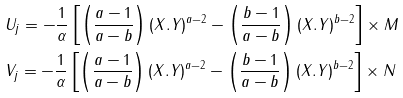<formula> <loc_0><loc_0><loc_500><loc_500>& U _ { j } = - \frac { 1 } { \alpha } \left [ \left ( \frac { a - 1 } { a - b } \right ) ( X . Y ) ^ { a - 2 } - \left ( \frac { b - 1 } { a - b } \right ) ( X . Y ) ^ { b - 2 } \right ] \times M \\ & V _ { j } = - \frac { 1 } { \alpha } \left [ \left ( \frac { a - 1 } { a - b } \right ) ( X . Y ) ^ { a - 2 } - \left ( \frac { b - 1 } { a - b } \right ) ( X . Y ) ^ { b - 2 } \right ] \times N</formula> 